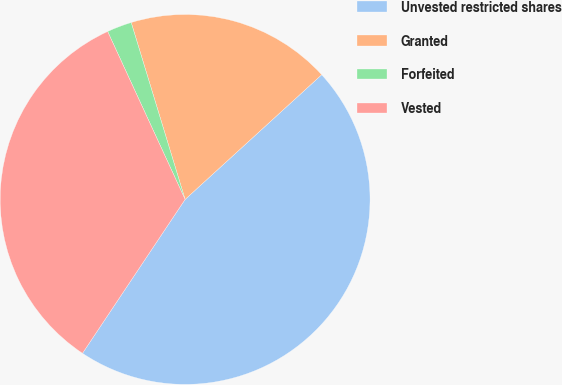<chart> <loc_0><loc_0><loc_500><loc_500><pie_chart><fcel>Unvested restricted shares<fcel>Granted<fcel>Forfeited<fcel>Vested<nl><fcel>46.14%<fcel>17.93%<fcel>2.17%<fcel>33.76%<nl></chart> 